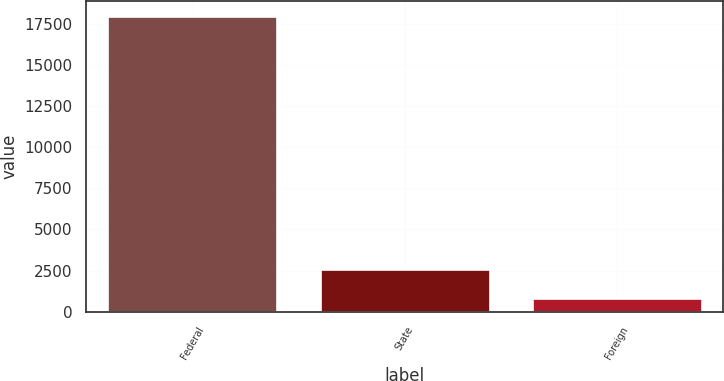Convert chart to OTSL. <chart><loc_0><loc_0><loc_500><loc_500><bar_chart><fcel>Federal<fcel>State<fcel>Foreign<nl><fcel>17989<fcel>2571.1<fcel>858<nl></chart> 